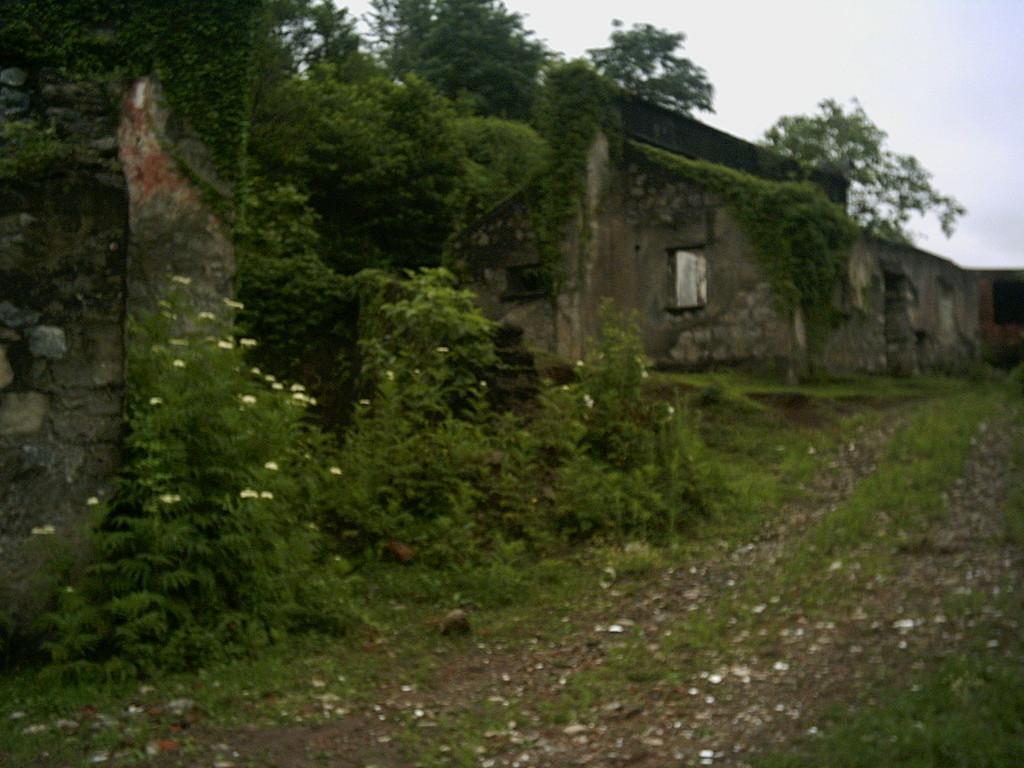Describe this image in one or two sentences. In this image there are few old buildings, there are few trees, plants, flowers, stones and the sky. 